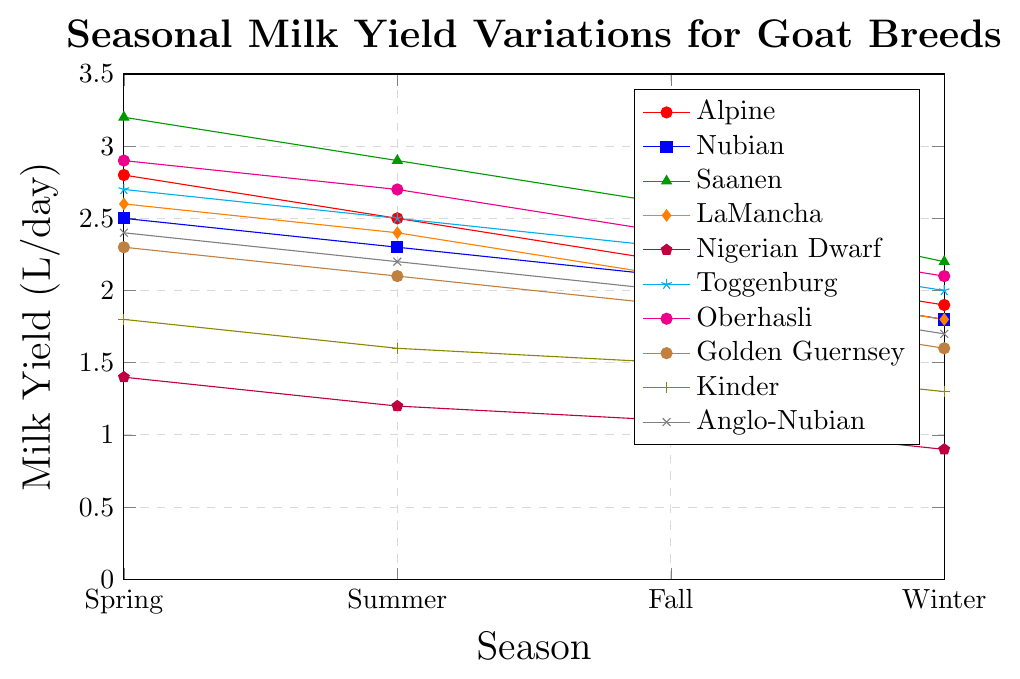Which goat breed has the highest milk yield in Spring? To determine which breed has the highest milk yield in Spring, look at the first data point (Spring) for each breed. The values are: Alpine (2.8), Nubian (2.5), Saanen (3.2), LaMancha (2.6), Nigerian Dwarf (1.4), Toggenburg (2.7), Oberhasli (2.9), Golden Guernsey (2.3), Kinder (1.8), Anglo-Nubian (2.4). Saanen has the highest yield at 3.2.
Answer: Saanen How does the milk yield of Nigerian Dwarf in Summer compare to its yield in Winter? Check the milk yield values for Nigerian Dwarf in Summer and Winter. The values are Summer (1.2) and Winter (0.9). Compare these values; 1.2 is greater than 0.9.
Answer: Greater in Summer What is the average milk yield for Kinder across all seasons? Calculate the average by summing the yields for each season and dividing by the number of seasons. (1.8 + 1.6 + 1.5 + 1.3) / 4. The sum is 6.2, and the average is 6.2 / 4 = 1.55.
Answer: 1.55 Which season shows the highest milk yield for Toggenburg? Look at the data points for Toggenburg for each season: Spring (2.7), Summer (2.5), Fall (2.3), Winter (2.0). The highest value is in Spring at 2.7.
Answer: Spring By how much does the milk yield of Alpine decrease from Spring to Winter? Identify the yield in Spring (2.8) and Winter (1.9) for Alpine. Subtract the Winter value from the Spring value: 2.8 - 1.9 = 0.9.
Answer: 0.9 Compare the milk yield in Summer for Saanen and Oberhasli. Which has a higher yield, and by how much? Saanen's yield in Summer is 2.9, and Oberhasli's is 2.7. Subtract Oberhasli's yield from Saanen's: 2.9 - 2.7 = 0.2. Saanen has a higher yield by 0.2.
Answer: Saanen by 0.2 What is the difference in milk yield between Golden Guernsey and Anglo-Nubian in Fall? Check their yields in Fall: Golden Guernsey (1.9) and Anglo-Nubian (2.0). Calculate the difference: 2.0 - 1.9 = 0.1.
Answer: 0.1 Which goat breed has the lowest milk yield in Winter? Determine the Winter yield for each breed and find the lowest value. The values are: Alpine (1.9), Nubian (1.8), Saanen (2.2), LaMancha (1.8), Nigerian Dwarf (0.9), Toggenburg (2.0), Oberhasli (2.1), Golden Guernsey (1.6), Kinder (1.3), Anglo-Nubian (1.7). The lowest is Nigerian Dwarf at 0.9.
Answer: Nigerian Dwarf What is the total milk yield produced by Nubian throughout all seasons? Sum the yields for each season for Nubian: (2.5 + 2.3 + 2.1 + 1.8). The sum is 2.5 + 2.3 + 2.1 + 1.8 = 8.7.
Answer: 8.7 